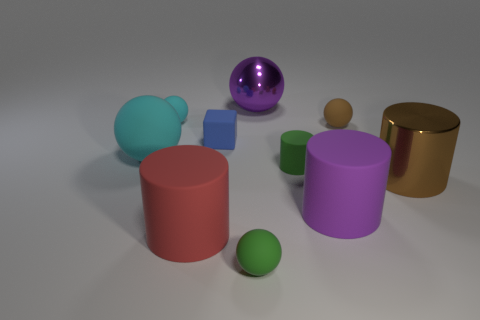Subtract all large shiny spheres. How many spheres are left? 4 Subtract all green spheres. How many spheres are left? 4 Subtract all red spheres. How many yellow cylinders are left? 0 Subtract all big brown rubber cylinders. Subtract all small cubes. How many objects are left? 9 Add 5 tiny objects. How many tiny objects are left? 10 Add 4 cyan rubber spheres. How many cyan rubber spheres exist? 6 Subtract 0 blue cylinders. How many objects are left? 10 Subtract all cylinders. How many objects are left? 6 Subtract 2 balls. How many balls are left? 3 Subtract all green cylinders. Subtract all yellow spheres. How many cylinders are left? 3 